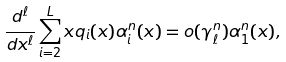<formula> <loc_0><loc_0><loc_500><loc_500>\frac { d ^ { \ell } } { d x ^ { \ell } } \sum _ { i = 2 } ^ { L } x q _ { i } ( x ) \alpha _ { i } ^ { n } ( x ) = o ( \gamma ^ { n } _ { \ell } ) \alpha _ { 1 } ^ { n } ( x ) ,</formula> 